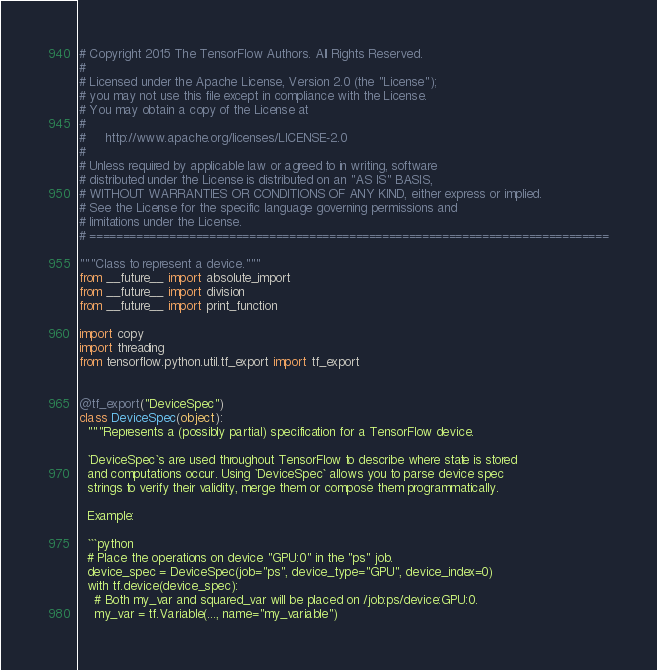<code> <loc_0><loc_0><loc_500><loc_500><_Python_># Copyright 2015 The TensorFlow Authors. All Rights Reserved.
#
# Licensed under the Apache License, Version 2.0 (the "License");
# you may not use this file except in compliance with the License.
# You may obtain a copy of the License at
#
#     http://www.apache.org/licenses/LICENSE-2.0
#
# Unless required by applicable law or agreed to in writing, software
# distributed under the License is distributed on an "AS IS" BASIS,
# WITHOUT WARRANTIES OR CONDITIONS OF ANY KIND, either express or implied.
# See the License for the specific language governing permissions and
# limitations under the License.
# ==============================================================================

"""Class to represent a device."""
from __future__ import absolute_import
from __future__ import division
from __future__ import print_function

import copy
import threading
from tensorflow.python.util.tf_export import tf_export


@tf_export("DeviceSpec")
class DeviceSpec(object):
  """Represents a (possibly partial) specification for a TensorFlow device.

  `DeviceSpec`s are used throughout TensorFlow to describe where state is stored
  and computations occur. Using `DeviceSpec` allows you to parse device spec
  strings to verify their validity, merge them or compose them programmatically.

  Example:

  ```python
  # Place the operations on device "GPU:0" in the "ps" job.
  device_spec = DeviceSpec(job="ps", device_type="GPU", device_index=0)
  with tf.device(device_spec):
    # Both my_var and squared_var will be placed on /job:ps/device:GPU:0.
    my_var = tf.Variable(..., name="my_variable")</code> 